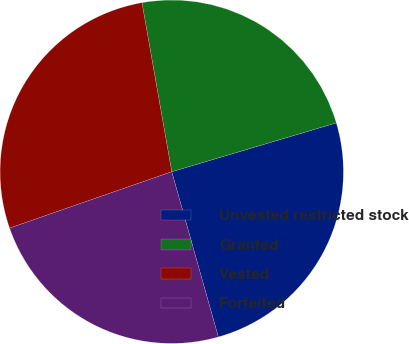<chart> <loc_0><loc_0><loc_500><loc_500><pie_chart><fcel>Unvested restricted stock<fcel>Granted<fcel>Vested<fcel>Forfeited<nl><fcel>25.22%<fcel>23.18%<fcel>27.55%<fcel>24.05%<nl></chart> 